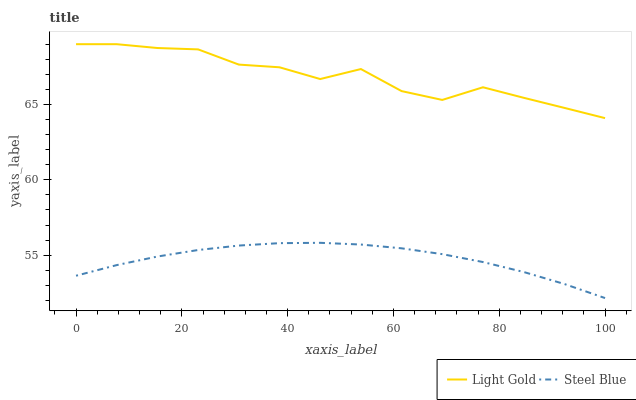Does Steel Blue have the minimum area under the curve?
Answer yes or no. Yes. Does Light Gold have the maximum area under the curve?
Answer yes or no. Yes. Does Steel Blue have the maximum area under the curve?
Answer yes or no. No. Is Steel Blue the smoothest?
Answer yes or no. Yes. Is Light Gold the roughest?
Answer yes or no. Yes. Is Steel Blue the roughest?
Answer yes or no. No. Does Steel Blue have the lowest value?
Answer yes or no. Yes. Does Light Gold have the highest value?
Answer yes or no. Yes. Does Steel Blue have the highest value?
Answer yes or no. No. Is Steel Blue less than Light Gold?
Answer yes or no. Yes. Is Light Gold greater than Steel Blue?
Answer yes or no. Yes. Does Steel Blue intersect Light Gold?
Answer yes or no. No. 